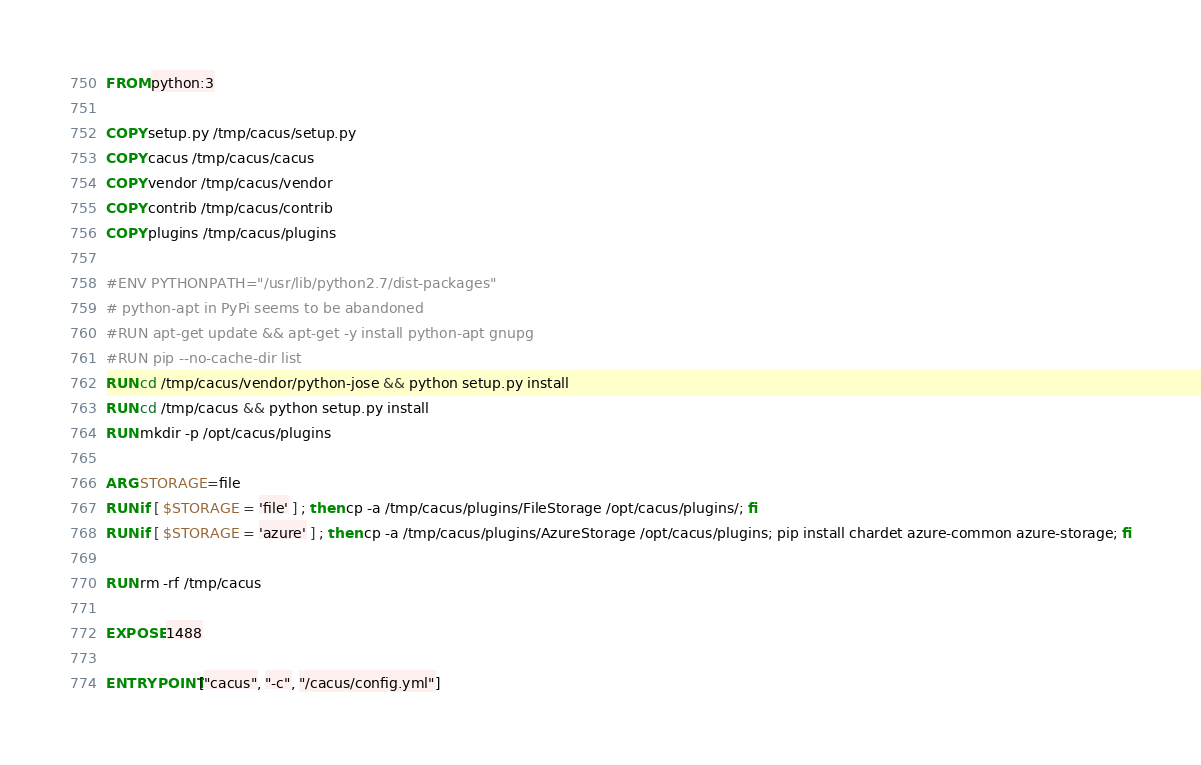Convert code to text. <code><loc_0><loc_0><loc_500><loc_500><_Dockerfile_>FROM python:3

COPY setup.py /tmp/cacus/setup.py
COPY cacus /tmp/cacus/cacus
COPY vendor /tmp/cacus/vendor
COPY contrib /tmp/cacus/contrib
COPY plugins /tmp/cacus/plugins

#ENV PYTHONPATH="/usr/lib/python2.7/dist-packages"
# python-apt in PyPi seems to be abandoned
#RUN apt-get update && apt-get -y install python-apt gnupg
#RUN pip --no-cache-dir list
RUN cd /tmp/cacus/vendor/python-jose && python setup.py install
RUN cd /tmp/cacus && python setup.py install
RUN mkdir -p /opt/cacus/plugins

ARG STORAGE=file
RUN if [ $STORAGE = 'file' ] ; then cp -a /tmp/cacus/plugins/FileStorage /opt/cacus/plugins/; fi
RUN if [ $STORAGE = 'azure' ] ; then cp -a /tmp/cacus/plugins/AzureStorage /opt/cacus/plugins; pip install chardet azure-common azure-storage; fi

RUN rm -rf /tmp/cacus

EXPOSE 1488

ENTRYPOINT ["cacus", "-c", "/cacus/config.yml"]
</code> 